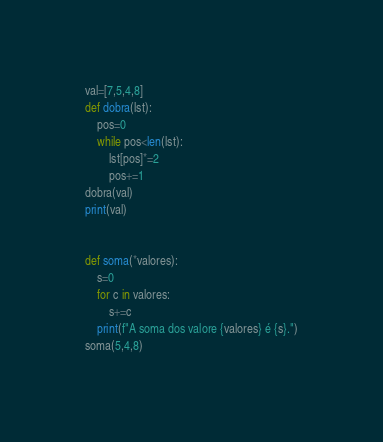<code> <loc_0><loc_0><loc_500><loc_500><_Python_>val=[7,5,4,8]
def dobra(lst):
    pos=0
    while pos<len(lst):
        lst[pos]*=2
        pos+=1
dobra(val)
print(val)


def soma(*valores):
    s=0
    for c in valores:
        s+=c
    print(f"A soma dos valore {valores} é {s}.")
soma(5,4,8)</code> 